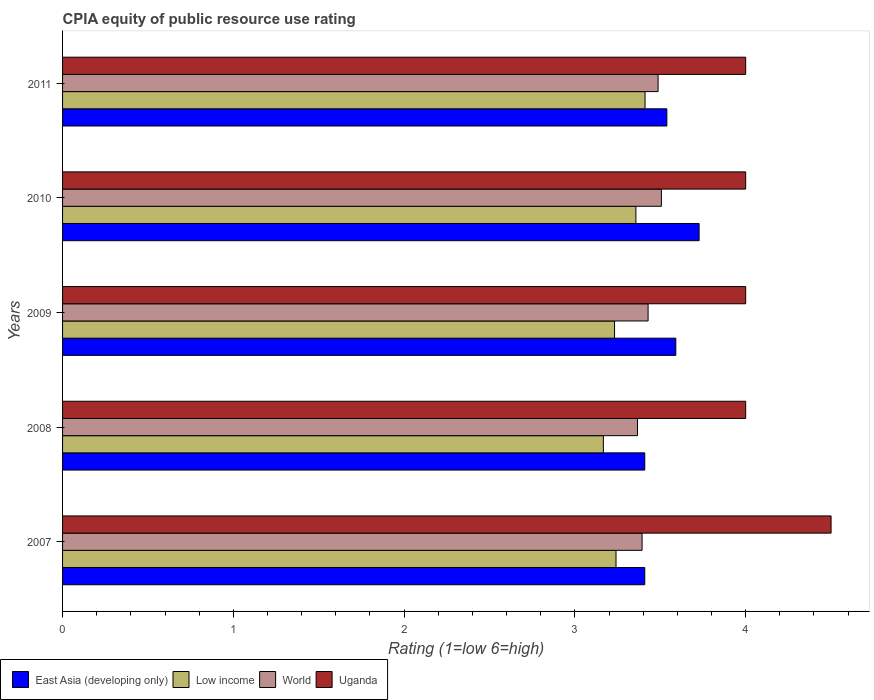How many different coloured bars are there?
Provide a succinct answer. 4. How many bars are there on the 1st tick from the top?
Give a very brief answer. 4. What is the label of the 4th group of bars from the top?
Give a very brief answer. 2008. In how many cases, is the number of bars for a given year not equal to the number of legend labels?
Offer a very short reply. 0. What is the CPIA rating in East Asia (developing only) in 2011?
Give a very brief answer. 3.54. Across all years, what is the maximum CPIA rating in Low income?
Keep it short and to the point. 3.41. Across all years, what is the minimum CPIA rating in World?
Provide a short and direct response. 3.37. In which year was the CPIA rating in East Asia (developing only) maximum?
Keep it short and to the point. 2010. In which year was the CPIA rating in East Asia (developing only) minimum?
Your response must be concise. 2007. What is the total CPIA rating in Uganda in the graph?
Your answer should be compact. 20.5. What is the difference between the CPIA rating in Uganda in 2007 and that in 2010?
Offer a terse response. 0.5. What is the difference between the CPIA rating in Uganda in 2011 and the CPIA rating in East Asia (developing only) in 2008?
Keep it short and to the point. 0.59. What is the average CPIA rating in East Asia (developing only) per year?
Your answer should be compact. 3.53. In the year 2009, what is the difference between the CPIA rating in Low income and CPIA rating in East Asia (developing only)?
Keep it short and to the point. -0.36. In how many years, is the CPIA rating in Low income greater than 1.4 ?
Your answer should be compact. 5. What is the ratio of the CPIA rating in Low income in 2007 to that in 2010?
Your answer should be very brief. 0.97. Is the CPIA rating in Low income in 2008 less than that in 2011?
Give a very brief answer. Yes. What is the difference between the highest and the second highest CPIA rating in Low income?
Offer a terse response. 0.05. What is the difference between the highest and the lowest CPIA rating in Low income?
Keep it short and to the point. 0.24. Is the sum of the CPIA rating in World in 2007 and 2008 greater than the maximum CPIA rating in East Asia (developing only) across all years?
Ensure brevity in your answer.  Yes. What does the 2nd bar from the bottom in 2011 represents?
Your response must be concise. Low income. How many bars are there?
Your answer should be compact. 20. Are all the bars in the graph horizontal?
Your answer should be compact. Yes. How many years are there in the graph?
Offer a very short reply. 5. What is the title of the graph?
Your answer should be very brief. CPIA equity of public resource use rating. Does "Fiji" appear as one of the legend labels in the graph?
Provide a succinct answer. No. What is the Rating (1=low 6=high) of East Asia (developing only) in 2007?
Make the answer very short. 3.41. What is the Rating (1=low 6=high) in Low income in 2007?
Your response must be concise. 3.24. What is the Rating (1=low 6=high) of World in 2007?
Give a very brief answer. 3.39. What is the Rating (1=low 6=high) in Uganda in 2007?
Offer a very short reply. 4.5. What is the Rating (1=low 6=high) in East Asia (developing only) in 2008?
Your response must be concise. 3.41. What is the Rating (1=low 6=high) in Low income in 2008?
Offer a terse response. 3.17. What is the Rating (1=low 6=high) of World in 2008?
Offer a very short reply. 3.37. What is the Rating (1=low 6=high) in Uganda in 2008?
Provide a short and direct response. 4. What is the Rating (1=low 6=high) in East Asia (developing only) in 2009?
Your answer should be compact. 3.59. What is the Rating (1=low 6=high) of Low income in 2009?
Keep it short and to the point. 3.23. What is the Rating (1=low 6=high) of World in 2009?
Keep it short and to the point. 3.43. What is the Rating (1=low 6=high) in East Asia (developing only) in 2010?
Your answer should be very brief. 3.73. What is the Rating (1=low 6=high) of Low income in 2010?
Offer a terse response. 3.36. What is the Rating (1=low 6=high) of World in 2010?
Your response must be concise. 3.51. What is the Rating (1=low 6=high) of East Asia (developing only) in 2011?
Your response must be concise. 3.54. What is the Rating (1=low 6=high) in Low income in 2011?
Give a very brief answer. 3.41. What is the Rating (1=low 6=high) in World in 2011?
Keep it short and to the point. 3.49. What is the Rating (1=low 6=high) of Uganda in 2011?
Keep it short and to the point. 4. Across all years, what is the maximum Rating (1=low 6=high) in East Asia (developing only)?
Make the answer very short. 3.73. Across all years, what is the maximum Rating (1=low 6=high) in Low income?
Your response must be concise. 3.41. Across all years, what is the maximum Rating (1=low 6=high) in World?
Ensure brevity in your answer.  3.51. Across all years, what is the minimum Rating (1=low 6=high) in East Asia (developing only)?
Ensure brevity in your answer.  3.41. Across all years, what is the minimum Rating (1=low 6=high) in Low income?
Your response must be concise. 3.17. Across all years, what is the minimum Rating (1=low 6=high) in World?
Your answer should be compact. 3.37. Across all years, what is the minimum Rating (1=low 6=high) of Uganda?
Ensure brevity in your answer.  4. What is the total Rating (1=low 6=high) in East Asia (developing only) in the graph?
Ensure brevity in your answer.  17.67. What is the total Rating (1=low 6=high) in Low income in the graph?
Your answer should be very brief. 16.41. What is the total Rating (1=low 6=high) of World in the graph?
Your answer should be compact. 17.18. What is the difference between the Rating (1=low 6=high) in East Asia (developing only) in 2007 and that in 2008?
Keep it short and to the point. 0. What is the difference between the Rating (1=low 6=high) of Low income in 2007 and that in 2008?
Give a very brief answer. 0.07. What is the difference between the Rating (1=low 6=high) of World in 2007 and that in 2008?
Give a very brief answer. 0.03. What is the difference between the Rating (1=low 6=high) of East Asia (developing only) in 2007 and that in 2009?
Provide a short and direct response. -0.18. What is the difference between the Rating (1=low 6=high) in Low income in 2007 and that in 2009?
Offer a very short reply. 0.01. What is the difference between the Rating (1=low 6=high) of World in 2007 and that in 2009?
Your response must be concise. -0.04. What is the difference between the Rating (1=low 6=high) of East Asia (developing only) in 2007 and that in 2010?
Ensure brevity in your answer.  -0.32. What is the difference between the Rating (1=low 6=high) of Low income in 2007 and that in 2010?
Keep it short and to the point. -0.12. What is the difference between the Rating (1=low 6=high) in World in 2007 and that in 2010?
Ensure brevity in your answer.  -0.11. What is the difference between the Rating (1=low 6=high) of East Asia (developing only) in 2007 and that in 2011?
Your answer should be compact. -0.13. What is the difference between the Rating (1=low 6=high) of Low income in 2007 and that in 2011?
Give a very brief answer. -0.17. What is the difference between the Rating (1=low 6=high) in World in 2007 and that in 2011?
Make the answer very short. -0.09. What is the difference between the Rating (1=low 6=high) of Uganda in 2007 and that in 2011?
Your response must be concise. 0.5. What is the difference between the Rating (1=low 6=high) in East Asia (developing only) in 2008 and that in 2009?
Provide a succinct answer. -0.18. What is the difference between the Rating (1=low 6=high) of Low income in 2008 and that in 2009?
Ensure brevity in your answer.  -0.07. What is the difference between the Rating (1=low 6=high) of World in 2008 and that in 2009?
Your answer should be compact. -0.06. What is the difference between the Rating (1=low 6=high) of East Asia (developing only) in 2008 and that in 2010?
Keep it short and to the point. -0.32. What is the difference between the Rating (1=low 6=high) of Low income in 2008 and that in 2010?
Provide a succinct answer. -0.19. What is the difference between the Rating (1=low 6=high) in World in 2008 and that in 2010?
Offer a terse response. -0.14. What is the difference between the Rating (1=low 6=high) in Uganda in 2008 and that in 2010?
Make the answer very short. 0. What is the difference between the Rating (1=low 6=high) of East Asia (developing only) in 2008 and that in 2011?
Offer a very short reply. -0.13. What is the difference between the Rating (1=low 6=high) of Low income in 2008 and that in 2011?
Offer a very short reply. -0.24. What is the difference between the Rating (1=low 6=high) in World in 2008 and that in 2011?
Offer a terse response. -0.12. What is the difference between the Rating (1=low 6=high) of Uganda in 2008 and that in 2011?
Your answer should be compact. 0. What is the difference between the Rating (1=low 6=high) in East Asia (developing only) in 2009 and that in 2010?
Offer a terse response. -0.14. What is the difference between the Rating (1=low 6=high) in Low income in 2009 and that in 2010?
Offer a terse response. -0.12. What is the difference between the Rating (1=low 6=high) of World in 2009 and that in 2010?
Offer a very short reply. -0.08. What is the difference between the Rating (1=low 6=high) of East Asia (developing only) in 2009 and that in 2011?
Ensure brevity in your answer.  0.05. What is the difference between the Rating (1=low 6=high) of Low income in 2009 and that in 2011?
Make the answer very short. -0.18. What is the difference between the Rating (1=low 6=high) of World in 2009 and that in 2011?
Provide a succinct answer. -0.06. What is the difference between the Rating (1=low 6=high) in East Asia (developing only) in 2010 and that in 2011?
Offer a very short reply. 0.19. What is the difference between the Rating (1=low 6=high) in Low income in 2010 and that in 2011?
Keep it short and to the point. -0.05. What is the difference between the Rating (1=low 6=high) of World in 2010 and that in 2011?
Ensure brevity in your answer.  0.02. What is the difference between the Rating (1=low 6=high) of East Asia (developing only) in 2007 and the Rating (1=low 6=high) of Low income in 2008?
Ensure brevity in your answer.  0.24. What is the difference between the Rating (1=low 6=high) of East Asia (developing only) in 2007 and the Rating (1=low 6=high) of World in 2008?
Give a very brief answer. 0.04. What is the difference between the Rating (1=low 6=high) in East Asia (developing only) in 2007 and the Rating (1=low 6=high) in Uganda in 2008?
Your response must be concise. -0.59. What is the difference between the Rating (1=low 6=high) of Low income in 2007 and the Rating (1=low 6=high) of World in 2008?
Provide a short and direct response. -0.13. What is the difference between the Rating (1=low 6=high) of Low income in 2007 and the Rating (1=low 6=high) of Uganda in 2008?
Make the answer very short. -0.76. What is the difference between the Rating (1=low 6=high) of World in 2007 and the Rating (1=low 6=high) of Uganda in 2008?
Offer a very short reply. -0.61. What is the difference between the Rating (1=low 6=high) of East Asia (developing only) in 2007 and the Rating (1=low 6=high) of Low income in 2009?
Give a very brief answer. 0.18. What is the difference between the Rating (1=low 6=high) in East Asia (developing only) in 2007 and the Rating (1=low 6=high) in World in 2009?
Offer a very short reply. -0.02. What is the difference between the Rating (1=low 6=high) in East Asia (developing only) in 2007 and the Rating (1=low 6=high) in Uganda in 2009?
Your answer should be very brief. -0.59. What is the difference between the Rating (1=low 6=high) in Low income in 2007 and the Rating (1=low 6=high) in World in 2009?
Provide a succinct answer. -0.19. What is the difference between the Rating (1=low 6=high) in Low income in 2007 and the Rating (1=low 6=high) in Uganda in 2009?
Provide a succinct answer. -0.76. What is the difference between the Rating (1=low 6=high) in World in 2007 and the Rating (1=low 6=high) in Uganda in 2009?
Offer a terse response. -0.61. What is the difference between the Rating (1=low 6=high) of East Asia (developing only) in 2007 and the Rating (1=low 6=high) of Low income in 2010?
Keep it short and to the point. 0.05. What is the difference between the Rating (1=low 6=high) of East Asia (developing only) in 2007 and the Rating (1=low 6=high) of World in 2010?
Offer a terse response. -0.1. What is the difference between the Rating (1=low 6=high) of East Asia (developing only) in 2007 and the Rating (1=low 6=high) of Uganda in 2010?
Your answer should be very brief. -0.59. What is the difference between the Rating (1=low 6=high) of Low income in 2007 and the Rating (1=low 6=high) of World in 2010?
Provide a succinct answer. -0.27. What is the difference between the Rating (1=low 6=high) in Low income in 2007 and the Rating (1=low 6=high) in Uganda in 2010?
Provide a short and direct response. -0.76. What is the difference between the Rating (1=low 6=high) in World in 2007 and the Rating (1=low 6=high) in Uganda in 2010?
Keep it short and to the point. -0.61. What is the difference between the Rating (1=low 6=high) of East Asia (developing only) in 2007 and the Rating (1=low 6=high) of Low income in 2011?
Ensure brevity in your answer.  -0. What is the difference between the Rating (1=low 6=high) of East Asia (developing only) in 2007 and the Rating (1=low 6=high) of World in 2011?
Ensure brevity in your answer.  -0.08. What is the difference between the Rating (1=low 6=high) in East Asia (developing only) in 2007 and the Rating (1=low 6=high) in Uganda in 2011?
Provide a short and direct response. -0.59. What is the difference between the Rating (1=low 6=high) in Low income in 2007 and the Rating (1=low 6=high) in World in 2011?
Provide a succinct answer. -0.25. What is the difference between the Rating (1=low 6=high) of Low income in 2007 and the Rating (1=low 6=high) of Uganda in 2011?
Your response must be concise. -0.76. What is the difference between the Rating (1=low 6=high) in World in 2007 and the Rating (1=low 6=high) in Uganda in 2011?
Give a very brief answer. -0.61. What is the difference between the Rating (1=low 6=high) in East Asia (developing only) in 2008 and the Rating (1=low 6=high) in Low income in 2009?
Provide a short and direct response. 0.18. What is the difference between the Rating (1=low 6=high) of East Asia (developing only) in 2008 and the Rating (1=low 6=high) of World in 2009?
Give a very brief answer. -0.02. What is the difference between the Rating (1=low 6=high) of East Asia (developing only) in 2008 and the Rating (1=low 6=high) of Uganda in 2009?
Your answer should be compact. -0.59. What is the difference between the Rating (1=low 6=high) of Low income in 2008 and the Rating (1=low 6=high) of World in 2009?
Keep it short and to the point. -0.26. What is the difference between the Rating (1=low 6=high) in World in 2008 and the Rating (1=low 6=high) in Uganda in 2009?
Offer a very short reply. -0.63. What is the difference between the Rating (1=low 6=high) of East Asia (developing only) in 2008 and the Rating (1=low 6=high) of Low income in 2010?
Offer a terse response. 0.05. What is the difference between the Rating (1=low 6=high) in East Asia (developing only) in 2008 and the Rating (1=low 6=high) in World in 2010?
Your answer should be compact. -0.1. What is the difference between the Rating (1=low 6=high) of East Asia (developing only) in 2008 and the Rating (1=low 6=high) of Uganda in 2010?
Provide a short and direct response. -0.59. What is the difference between the Rating (1=low 6=high) of Low income in 2008 and the Rating (1=low 6=high) of World in 2010?
Provide a succinct answer. -0.34. What is the difference between the Rating (1=low 6=high) of World in 2008 and the Rating (1=low 6=high) of Uganda in 2010?
Provide a short and direct response. -0.63. What is the difference between the Rating (1=low 6=high) in East Asia (developing only) in 2008 and the Rating (1=low 6=high) in Low income in 2011?
Offer a very short reply. -0. What is the difference between the Rating (1=low 6=high) in East Asia (developing only) in 2008 and the Rating (1=low 6=high) in World in 2011?
Your answer should be very brief. -0.08. What is the difference between the Rating (1=low 6=high) of East Asia (developing only) in 2008 and the Rating (1=low 6=high) of Uganda in 2011?
Give a very brief answer. -0.59. What is the difference between the Rating (1=low 6=high) of Low income in 2008 and the Rating (1=low 6=high) of World in 2011?
Keep it short and to the point. -0.32. What is the difference between the Rating (1=low 6=high) of Low income in 2008 and the Rating (1=low 6=high) of Uganda in 2011?
Keep it short and to the point. -0.83. What is the difference between the Rating (1=low 6=high) in World in 2008 and the Rating (1=low 6=high) in Uganda in 2011?
Give a very brief answer. -0.63. What is the difference between the Rating (1=low 6=high) in East Asia (developing only) in 2009 and the Rating (1=low 6=high) in Low income in 2010?
Make the answer very short. 0.23. What is the difference between the Rating (1=low 6=high) of East Asia (developing only) in 2009 and the Rating (1=low 6=high) of World in 2010?
Make the answer very short. 0.08. What is the difference between the Rating (1=low 6=high) of East Asia (developing only) in 2009 and the Rating (1=low 6=high) of Uganda in 2010?
Your response must be concise. -0.41. What is the difference between the Rating (1=low 6=high) of Low income in 2009 and the Rating (1=low 6=high) of World in 2010?
Offer a terse response. -0.27. What is the difference between the Rating (1=low 6=high) in Low income in 2009 and the Rating (1=low 6=high) in Uganda in 2010?
Make the answer very short. -0.77. What is the difference between the Rating (1=low 6=high) of World in 2009 and the Rating (1=low 6=high) of Uganda in 2010?
Provide a short and direct response. -0.57. What is the difference between the Rating (1=low 6=high) of East Asia (developing only) in 2009 and the Rating (1=low 6=high) of Low income in 2011?
Your answer should be compact. 0.18. What is the difference between the Rating (1=low 6=high) in East Asia (developing only) in 2009 and the Rating (1=low 6=high) in World in 2011?
Offer a terse response. 0.1. What is the difference between the Rating (1=low 6=high) of East Asia (developing only) in 2009 and the Rating (1=low 6=high) of Uganda in 2011?
Your answer should be compact. -0.41. What is the difference between the Rating (1=low 6=high) of Low income in 2009 and the Rating (1=low 6=high) of World in 2011?
Your answer should be very brief. -0.26. What is the difference between the Rating (1=low 6=high) of Low income in 2009 and the Rating (1=low 6=high) of Uganda in 2011?
Keep it short and to the point. -0.77. What is the difference between the Rating (1=low 6=high) of World in 2009 and the Rating (1=low 6=high) of Uganda in 2011?
Provide a succinct answer. -0.57. What is the difference between the Rating (1=low 6=high) of East Asia (developing only) in 2010 and the Rating (1=low 6=high) of Low income in 2011?
Offer a terse response. 0.32. What is the difference between the Rating (1=low 6=high) of East Asia (developing only) in 2010 and the Rating (1=low 6=high) of World in 2011?
Your answer should be compact. 0.24. What is the difference between the Rating (1=low 6=high) of East Asia (developing only) in 2010 and the Rating (1=low 6=high) of Uganda in 2011?
Offer a terse response. -0.27. What is the difference between the Rating (1=low 6=high) of Low income in 2010 and the Rating (1=low 6=high) of World in 2011?
Keep it short and to the point. -0.13. What is the difference between the Rating (1=low 6=high) in Low income in 2010 and the Rating (1=low 6=high) in Uganda in 2011?
Keep it short and to the point. -0.64. What is the difference between the Rating (1=low 6=high) in World in 2010 and the Rating (1=low 6=high) in Uganda in 2011?
Keep it short and to the point. -0.49. What is the average Rating (1=low 6=high) in East Asia (developing only) per year?
Give a very brief answer. 3.54. What is the average Rating (1=low 6=high) of Low income per year?
Give a very brief answer. 3.28. What is the average Rating (1=low 6=high) in World per year?
Give a very brief answer. 3.44. In the year 2007, what is the difference between the Rating (1=low 6=high) in East Asia (developing only) and Rating (1=low 6=high) in Low income?
Offer a very short reply. 0.17. In the year 2007, what is the difference between the Rating (1=low 6=high) of East Asia (developing only) and Rating (1=low 6=high) of World?
Your answer should be very brief. 0.02. In the year 2007, what is the difference between the Rating (1=low 6=high) of East Asia (developing only) and Rating (1=low 6=high) of Uganda?
Offer a very short reply. -1.09. In the year 2007, what is the difference between the Rating (1=low 6=high) in Low income and Rating (1=low 6=high) in World?
Keep it short and to the point. -0.15. In the year 2007, what is the difference between the Rating (1=low 6=high) of Low income and Rating (1=low 6=high) of Uganda?
Provide a succinct answer. -1.26. In the year 2007, what is the difference between the Rating (1=low 6=high) of World and Rating (1=low 6=high) of Uganda?
Provide a succinct answer. -1.11. In the year 2008, what is the difference between the Rating (1=low 6=high) of East Asia (developing only) and Rating (1=low 6=high) of Low income?
Your answer should be compact. 0.24. In the year 2008, what is the difference between the Rating (1=low 6=high) in East Asia (developing only) and Rating (1=low 6=high) in World?
Your answer should be very brief. 0.04. In the year 2008, what is the difference between the Rating (1=low 6=high) of East Asia (developing only) and Rating (1=low 6=high) of Uganda?
Provide a succinct answer. -0.59. In the year 2008, what is the difference between the Rating (1=low 6=high) of World and Rating (1=low 6=high) of Uganda?
Your response must be concise. -0.63. In the year 2009, what is the difference between the Rating (1=low 6=high) in East Asia (developing only) and Rating (1=low 6=high) in Low income?
Make the answer very short. 0.36. In the year 2009, what is the difference between the Rating (1=low 6=high) in East Asia (developing only) and Rating (1=low 6=high) in World?
Your answer should be very brief. 0.16. In the year 2009, what is the difference between the Rating (1=low 6=high) of East Asia (developing only) and Rating (1=low 6=high) of Uganda?
Provide a short and direct response. -0.41. In the year 2009, what is the difference between the Rating (1=low 6=high) of Low income and Rating (1=low 6=high) of World?
Offer a very short reply. -0.2. In the year 2009, what is the difference between the Rating (1=low 6=high) of Low income and Rating (1=low 6=high) of Uganda?
Provide a succinct answer. -0.77. In the year 2009, what is the difference between the Rating (1=low 6=high) in World and Rating (1=low 6=high) in Uganda?
Keep it short and to the point. -0.57. In the year 2010, what is the difference between the Rating (1=low 6=high) of East Asia (developing only) and Rating (1=low 6=high) of Low income?
Give a very brief answer. 0.37. In the year 2010, what is the difference between the Rating (1=low 6=high) of East Asia (developing only) and Rating (1=low 6=high) of World?
Offer a very short reply. 0.22. In the year 2010, what is the difference between the Rating (1=low 6=high) of East Asia (developing only) and Rating (1=low 6=high) of Uganda?
Your answer should be very brief. -0.27. In the year 2010, what is the difference between the Rating (1=low 6=high) in Low income and Rating (1=low 6=high) in World?
Make the answer very short. -0.15. In the year 2010, what is the difference between the Rating (1=low 6=high) of Low income and Rating (1=low 6=high) of Uganda?
Provide a succinct answer. -0.64. In the year 2010, what is the difference between the Rating (1=low 6=high) of World and Rating (1=low 6=high) of Uganda?
Offer a very short reply. -0.49. In the year 2011, what is the difference between the Rating (1=low 6=high) of East Asia (developing only) and Rating (1=low 6=high) of Low income?
Your answer should be compact. 0.13. In the year 2011, what is the difference between the Rating (1=low 6=high) of East Asia (developing only) and Rating (1=low 6=high) of World?
Keep it short and to the point. 0.05. In the year 2011, what is the difference between the Rating (1=low 6=high) in East Asia (developing only) and Rating (1=low 6=high) in Uganda?
Give a very brief answer. -0.46. In the year 2011, what is the difference between the Rating (1=low 6=high) in Low income and Rating (1=low 6=high) in World?
Your answer should be compact. -0.08. In the year 2011, what is the difference between the Rating (1=low 6=high) of Low income and Rating (1=low 6=high) of Uganda?
Provide a short and direct response. -0.59. In the year 2011, what is the difference between the Rating (1=low 6=high) in World and Rating (1=low 6=high) in Uganda?
Your answer should be compact. -0.51. What is the ratio of the Rating (1=low 6=high) in East Asia (developing only) in 2007 to that in 2008?
Make the answer very short. 1. What is the ratio of the Rating (1=low 6=high) in Low income in 2007 to that in 2008?
Your response must be concise. 1.02. What is the ratio of the Rating (1=low 6=high) in World in 2007 to that in 2008?
Offer a very short reply. 1.01. What is the ratio of the Rating (1=low 6=high) in East Asia (developing only) in 2007 to that in 2009?
Offer a terse response. 0.95. What is the ratio of the Rating (1=low 6=high) of Low income in 2007 to that in 2009?
Provide a succinct answer. 1. What is the ratio of the Rating (1=low 6=high) in World in 2007 to that in 2009?
Provide a succinct answer. 0.99. What is the ratio of the Rating (1=low 6=high) of East Asia (developing only) in 2007 to that in 2010?
Make the answer very short. 0.91. What is the ratio of the Rating (1=low 6=high) of Low income in 2007 to that in 2010?
Make the answer very short. 0.97. What is the ratio of the Rating (1=low 6=high) in Uganda in 2007 to that in 2010?
Your response must be concise. 1.12. What is the ratio of the Rating (1=low 6=high) of East Asia (developing only) in 2007 to that in 2011?
Provide a succinct answer. 0.96. What is the ratio of the Rating (1=low 6=high) of Low income in 2007 to that in 2011?
Ensure brevity in your answer.  0.95. What is the ratio of the Rating (1=low 6=high) in World in 2007 to that in 2011?
Provide a succinct answer. 0.97. What is the ratio of the Rating (1=low 6=high) in East Asia (developing only) in 2008 to that in 2009?
Keep it short and to the point. 0.95. What is the ratio of the Rating (1=low 6=high) of Low income in 2008 to that in 2009?
Offer a terse response. 0.98. What is the ratio of the Rating (1=low 6=high) in World in 2008 to that in 2009?
Offer a terse response. 0.98. What is the ratio of the Rating (1=low 6=high) in East Asia (developing only) in 2008 to that in 2010?
Offer a very short reply. 0.91. What is the ratio of the Rating (1=low 6=high) in Low income in 2008 to that in 2010?
Your answer should be very brief. 0.94. What is the ratio of the Rating (1=low 6=high) in World in 2008 to that in 2010?
Your answer should be very brief. 0.96. What is the ratio of the Rating (1=low 6=high) of East Asia (developing only) in 2008 to that in 2011?
Your response must be concise. 0.96. What is the ratio of the Rating (1=low 6=high) in Low income in 2008 to that in 2011?
Make the answer very short. 0.93. What is the ratio of the Rating (1=low 6=high) of World in 2008 to that in 2011?
Your response must be concise. 0.97. What is the ratio of the Rating (1=low 6=high) of Uganda in 2008 to that in 2011?
Offer a very short reply. 1. What is the ratio of the Rating (1=low 6=high) of East Asia (developing only) in 2009 to that in 2010?
Your answer should be compact. 0.96. What is the ratio of the Rating (1=low 6=high) in Low income in 2009 to that in 2010?
Make the answer very short. 0.96. What is the ratio of the Rating (1=low 6=high) in World in 2009 to that in 2010?
Keep it short and to the point. 0.98. What is the ratio of the Rating (1=low 6=high) in Uganda in 2009 to that in 2010?
Your answer should be very brief. 1. What is the ratio of the Rating (1=low 6=high) in East Asia (developing only) in 2009 to that in 2011?
Offer a terse response. 1.01. What is the ratio of the Rating (1=low 6=high) in Low income in 2009 to that in 2011?
Provide a short and direct response. 0.95. What is the ratio of the Rating (1=low 6=high) in World in 2009 to that in 2011?
Provide a succinct answer. 0.98. What is the ratio of the Rating (1=low 6=high) in Uganda in 2009 to that in 2011?
Your answer should be compact. 1. What is the ratio of the Rating (1=low 6=high) of East Asia (developing only) in 2010 to that in 2011?
Make the answer very short. 1.05. What is the ratio of the Rating (1=low 6=high) in Low income in 2010 to that in 2011?
Provide a short and direct response. 0.98. What is the ratio of the Rating (1=low 6=high) of World in 2010 to that in 2011?
Give a very brief answer. 1.01. What is the ratio of the Rating (1=low 6=high) in Uganda in 2010 to that in 2011?
Provide a short and direct response. 1. What is the difference between the highest and the second highest Rating (1=low 6=high) of East Asia (developing only)?
Offer a terse response. 0.14. What is the difference between the highest and the second highest Rating (1=low 6=high) of Low income?
Give a very brief answer. 0.05. What is the difference between the highest and the second highest Rating (1=low 6=high) of World?
Offer a terse response. 0.02. What is the difference between the highest and the lowest Rating (1=low 6=high) in East Asia (developing only)?
Provide a short and direct response. 0.32. What is the difference between the highest and the lowest Rating (1=low 6=high) in Low income?
Give a very brief answer. 0.24. What is the difference between the highest and the lowest Rating (1=low 6=high) in World?
Make the answer very short. 0.14. What is the difference between the highest and the lowest Rating (1=low 6=high) of Uganda?
Give a very brief answer. 0.5. 